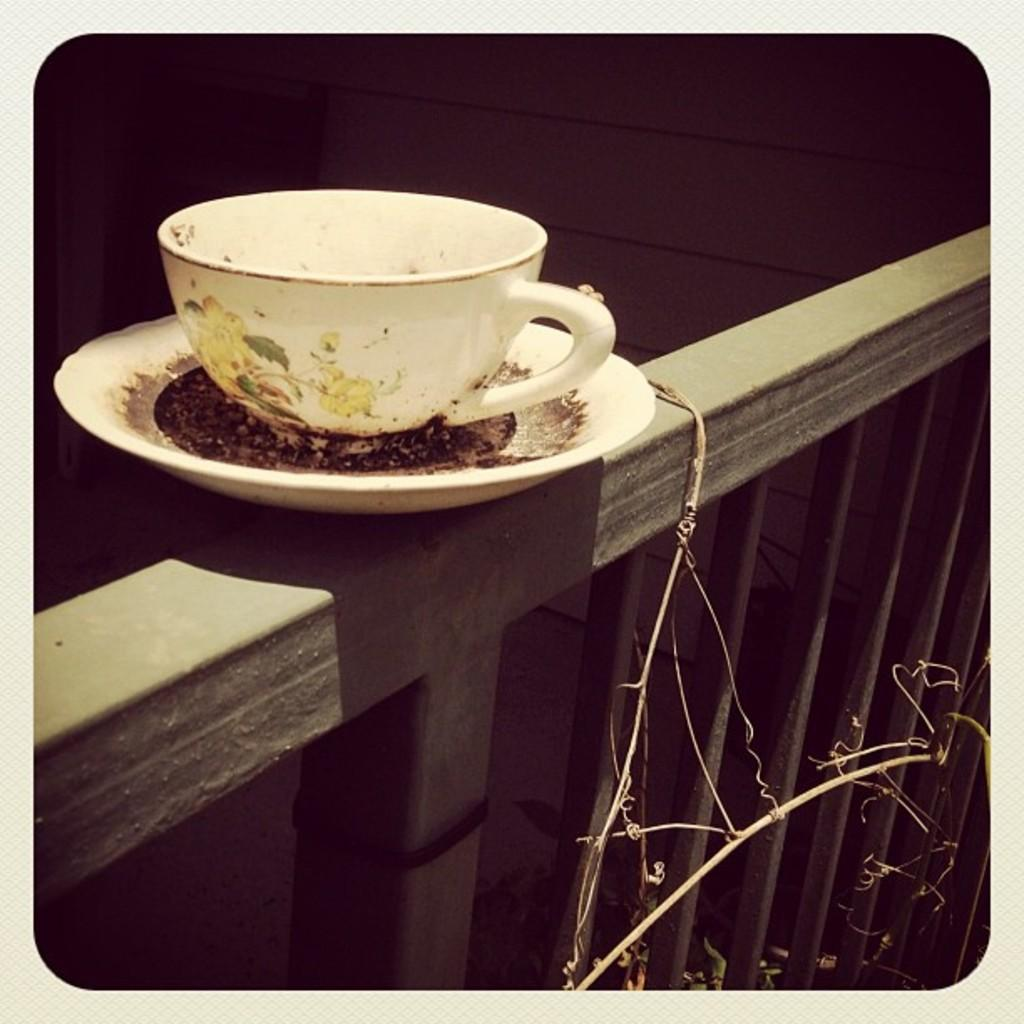What is present in the image that is typically used for holding liquids? There is a cup in the image, which is typically used for holding liquids. What is present in the image that is typically used for holding small objects? There is a saucer in the image, which is typically used for holding small objects. What type of structure can be seen in the image? There is a fence and a wall in the image, which are both types of structures. Can you describe the detail of the squirrel's fur in the image? There is no squirrel present in the image, so it is not possible to describe the detail of its fur. 